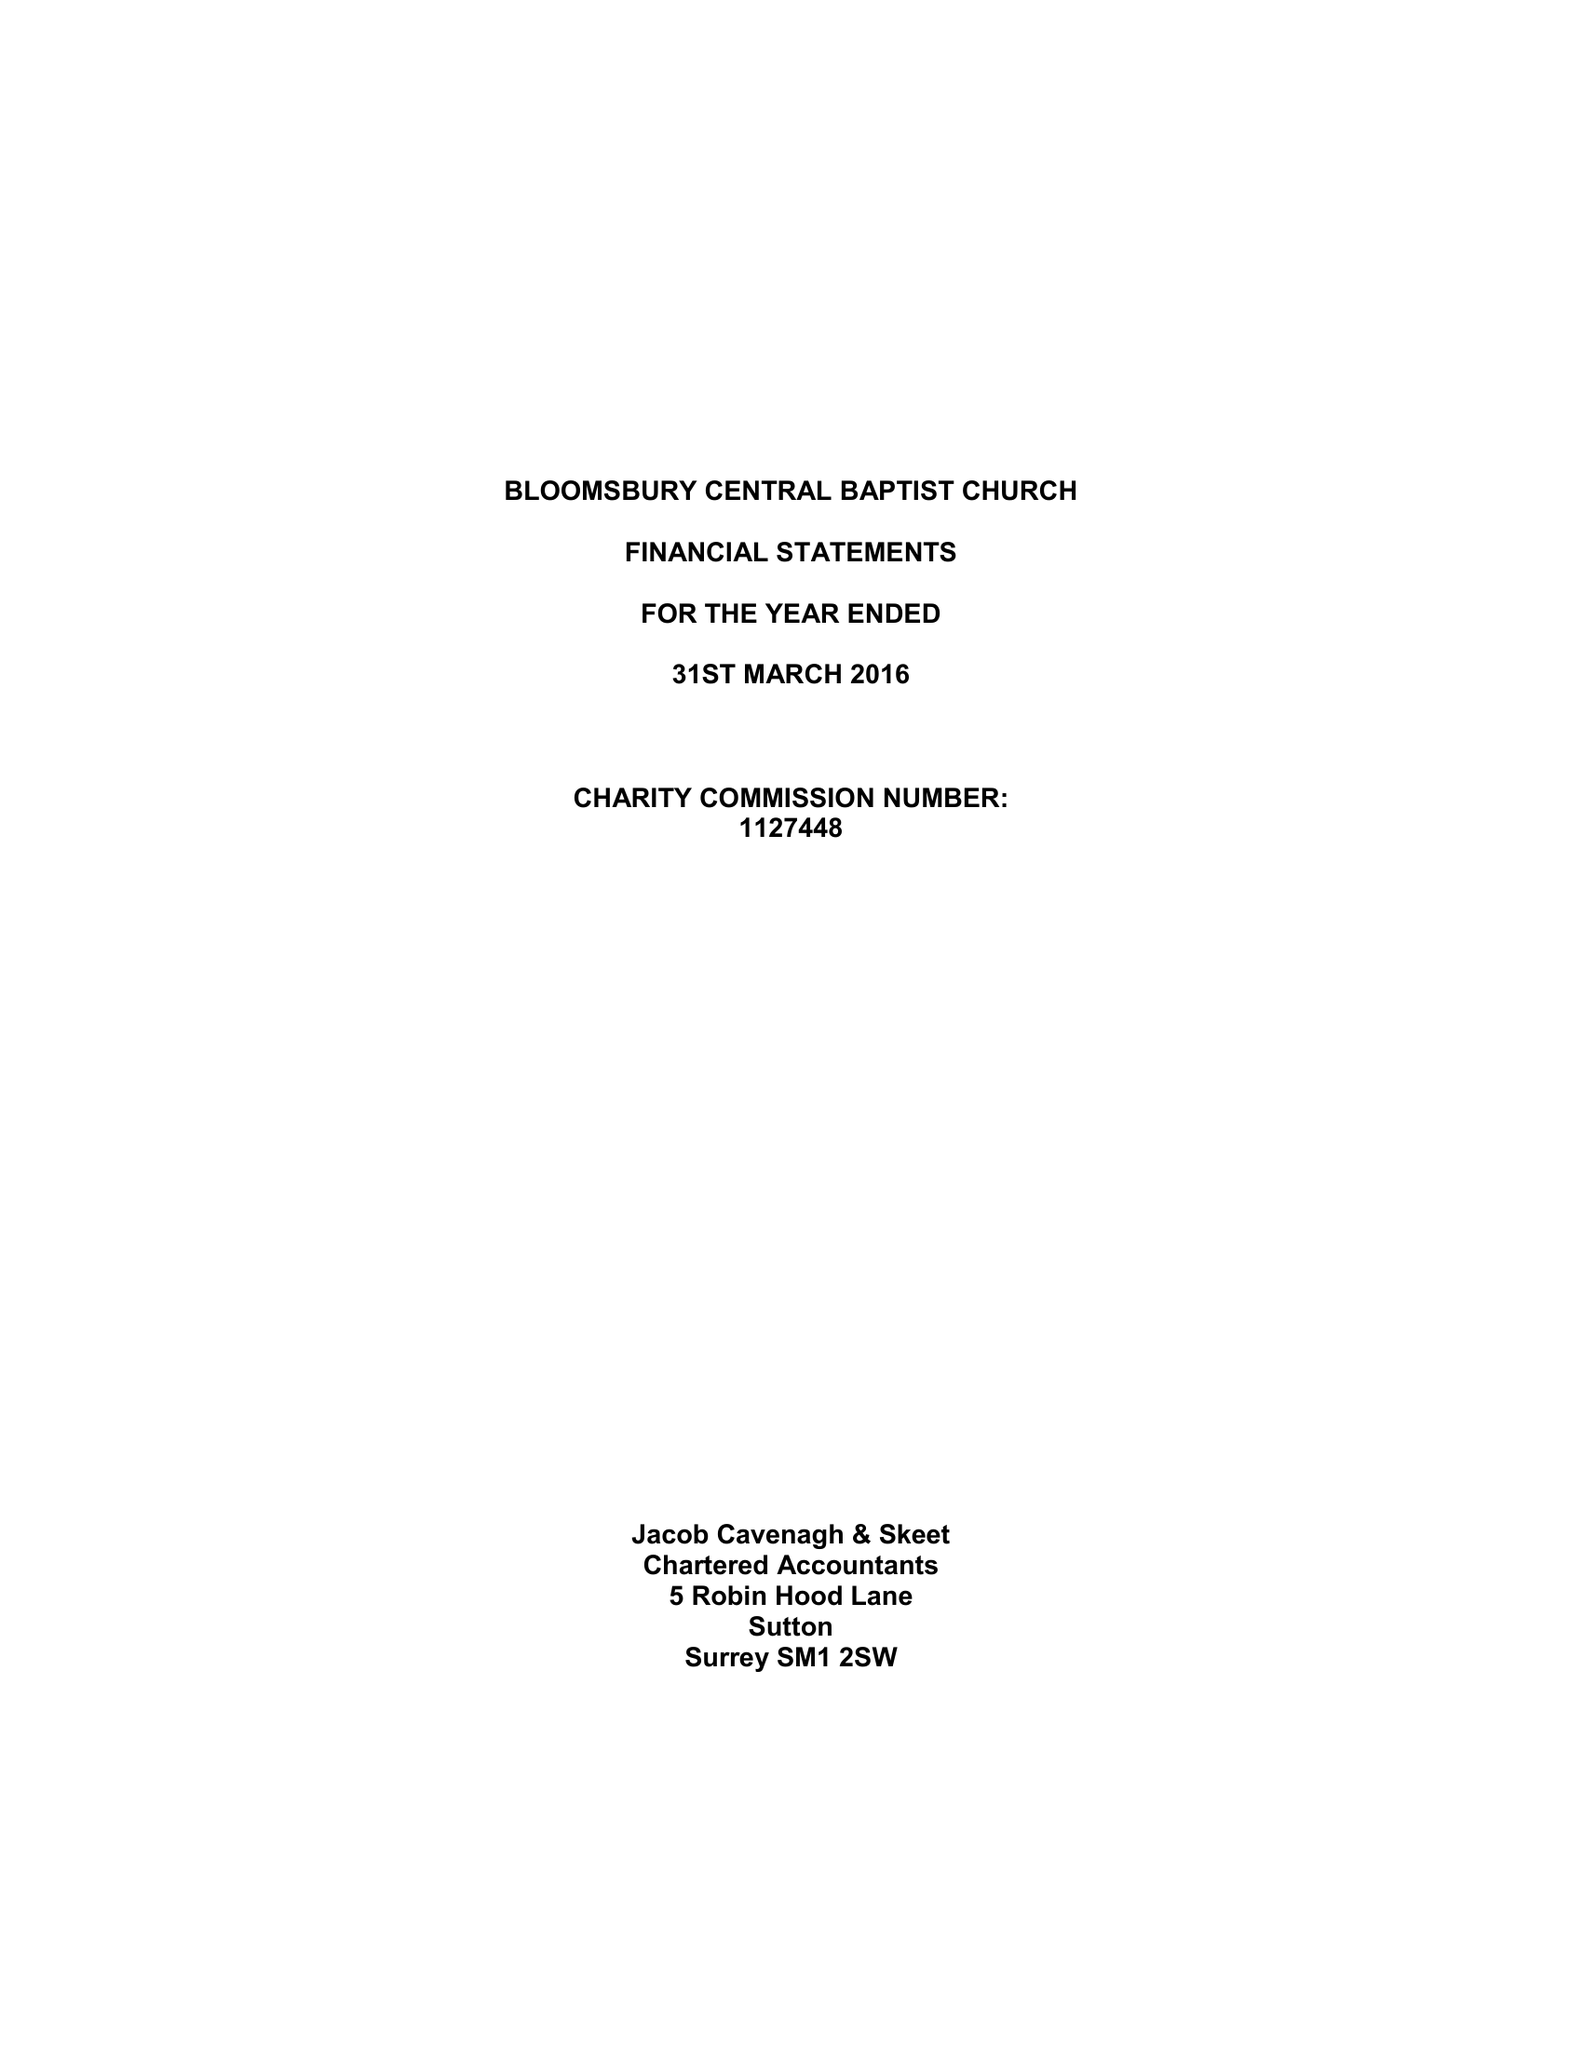What is the value for the spending_annually_in_british_pounds?
Answer the question using a single word or phrase. 460686.00 